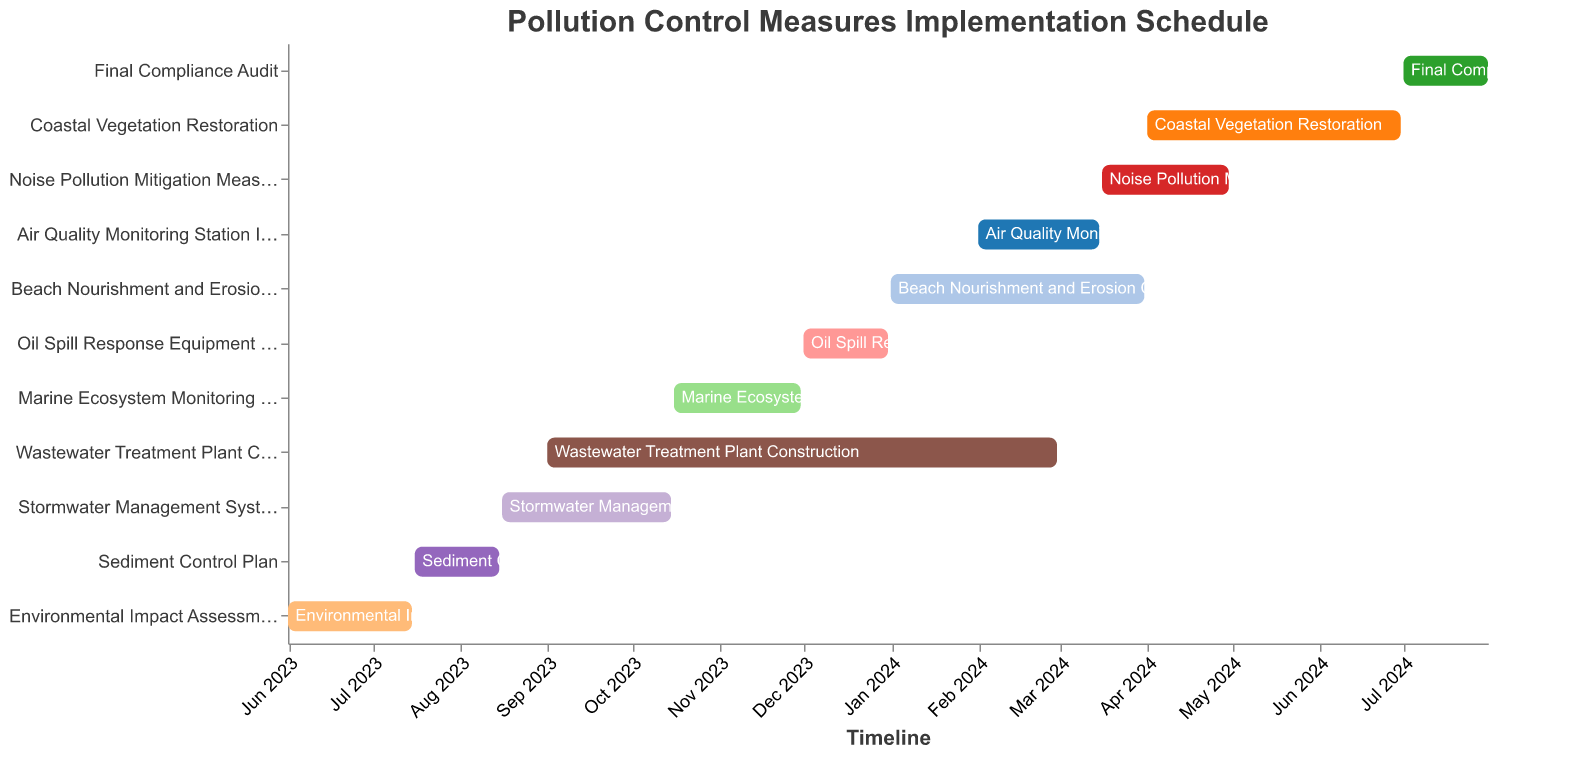What is the title of the Gantt Chart? The title is displayed at the top of the chart and indicates the main subject, which is the schedule for implementing pollution control measures.
Answer: Pollution Control Measures Implementation Schedule How many tasks are listed in the Gantt Chart? Count the number of different tasks listed on the Y-axis. There are 11 tasks in total.
Answer: 11 Which task takes the longest time to complete? Identify the tasks and compare their duration. "Wastewater Treatment Plant Construction" has the longest duration with 182 days.
Answer: Wastewater Treatment Plant Construction When does the "Beach Nourishment and Erosion Control" task begin and end? Look at the start and end dates for the specified task in the chart. It starts on January 1, 2024, and ends on March 31, 2024.
Answer: January 1, 2024; March 31, 2024 Which tasks are running concurrently with the "Marine Ecosystem Monitoring Setup"? Identify overlapping tasks by comparing start and end dates. "Wastewater Treatment Plant Construction" overlaps with "Marine Ecosystem Monitoring Setup" from October 16, 2023, to November 30, 2023.
Answer: Wastewater Treatment Plant Construction What is the duration of the "Air Quality Monitoring Station Installation" task, and how is it represented in the chart? Locate the task on the chart and refer to its duration. It spans 44 days from February 1, 2024, to March 15, 2024.
Answer: 44 days Which task follows directly after "Sediment Control Plan"? Check the end date of "Sediment Control Plan" and the start date of the following task. "Stormwater Management System Installation" follows directly, starting on August 16, 2023.
Answer: Stormwater Management System Installation How many tasks are scheduled to end in 2023? Identify tasks ending within the specified year by comparing their end dates. Four tasks end in 2023: "Environmental Impact Assessment," "Sediment Control Plan," "Stormwater Management System Installation," and "Marine Ecosystem Monitoring Setup."
Answer: 4 What is the total duration of tasks related to monitoring (i.e., "Marine Ecosystem Monitoring Setup" and "Air Quality Monitoring Station Installation")? Sum the durations of identified tasks. "Marine Ecosystem Monitoring Setup" (46 days) and "Air Quality Monitoring Station Installation" (44 days) combine for a total of 90 days.
Answer: 90 days Compare the durations of "Noise Pollution Mitigation Measures" and "Coastal Vegetation Restoration." Which one lasts longer and by how many days? Find the durations of both tasks and subtract the shorter duration from the longer one. "Noise Pollution Mitigation Measures" lasts 46 days, while "Coastal Vegetation Restoration" lasts 91 days, a difference of 45 days.
Answer: Coastal Vegetation Restoration by 45 days 